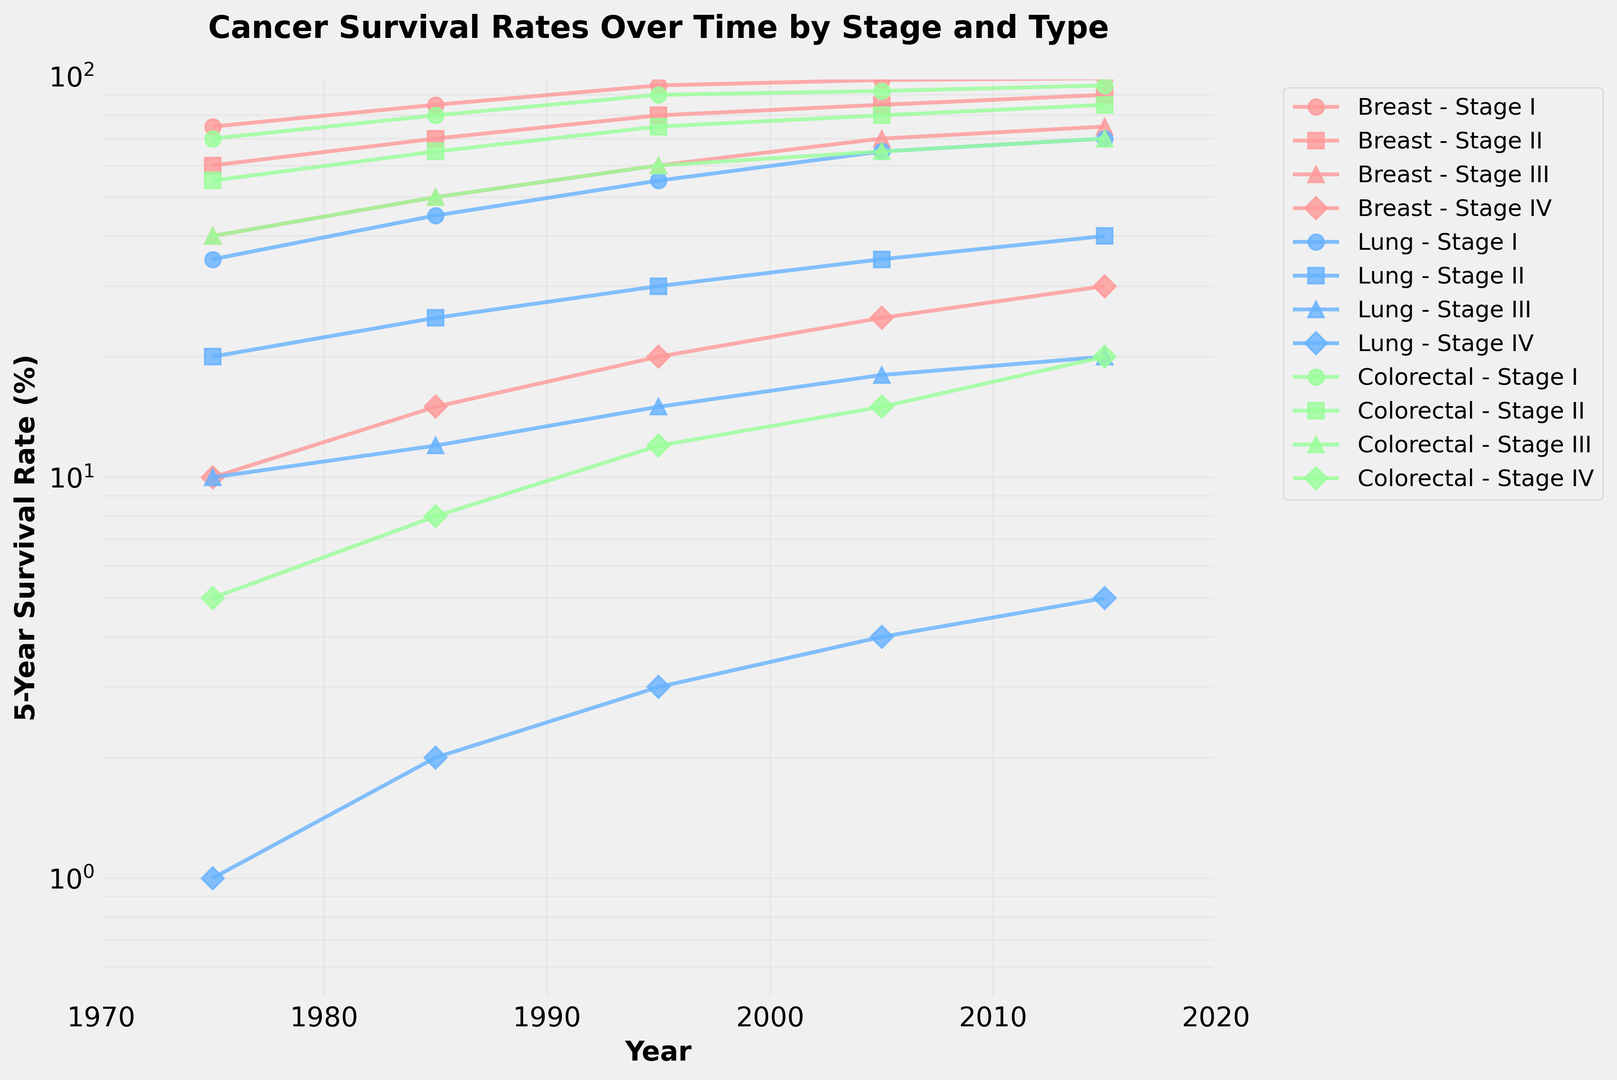What's the trend in the 5-year survival rate for Stage I Breast cancer from 1975 to 2015? The line corresponding to Stage I Breast cancer shows a consistent increase in survival rates over time. Observing the survival rate for Stage I Breast cancer at different time points—75% (1975), 85% (1985), 95% (1995), 98% (2005), and 99% (2015)—demonstrates this upward trend.
Answer: The survival rate increases Which cancer type had the lowest 5-year survival rate in 2015, and for which stage? We observe the lowest point on the graph in 2015 to find the minimum survival rate. Stage IV Lung cancer has the lowest survival rate in 2015, depicted by the Stage IV line for Lung cancer at approximately 5%.
Answer: Lung, Stage IV Between which two successive decades did Stage III Colorectal cancer show the greatest improvement in 5-year survival rate? Comparing the survival rate increments for each decade:
    - 1975 to 1985: 40% to 50% (10% increase)
    - 1985 to 1995: 50% to 60% (10% increase)
    - 1995 to 2005: 60% to 65% (5% increase)
    - 2005 to 2015: 65% to 70% (5% increase)
The greatest improvement of 10% is seen in both 1975-1985 and 1985-1995.
Answer: 1975 to 1985 and 1985 to 1995 Which cancer type has the highest 5-year survival rate in 2005 for Stage II, and what is that rate? Examining Stage II lines for the year 2005, Breast cancer shows an 85% survival rate, Lung cancer shows 35%, and Colorectal cancer shows 80%. Consequently, Breast cancer has the highest survival rate for Stage II in 2005.
Answer: Breast, 85% How does the 5-year survival rate for Stage IV cancers compare between Breast and Colorectal cancer in 2015? Locate Stage IV lines for both Breast and Colorectal cancers in 2015. Breast cancer shows a 30% survival rate, and Colorectal cancer shows 20%. Breast cancer’s survival rate is higher by 10%.
Answer: Breast cancer's rate is higher by 10% Which cancer type and stage had the most significant increase in survival rate from 1975 to 2015, and what is the total increase? By comparing starting (1975) and ending (2015) values for each stage:
    - Stage I Breast: 75% to 99% (24% increase)
    - Stage I Lung: 35% to 70% (35% increase)
    - Stage I Colorectal: 70% to 95% (25% increase)
    Lung cancer at Stage I shows the largest increase of 35% between 1975 and 2015.
Answer: Lung, Stage I, 35% What is the difference in 5-year survival rate for Stage III cancers of Lung and Colorectal cancer in 1995? Comparing the Stage III survival rates for Lung and Colorectal cancer in 1995:
    - Lung cancer: 15%
    - Colorectal cancer: 60%
The difference is 60% - 15% = 45%.
Answer: 45% For which stage and cancer type is there the smallest change in survival rates from 1975 to 2015? Reviewing survival rate changes:
    - Breast Stage IV: from 10% to 30% (20% change)
    - Lung Stage IV: from 1% to 5% (4% change)
    - Colorectal Stage IV: from 5% to 20% (15% change)
Lung cancer at Stage IV has the smallest change (4%).
Answer: Lung, Stage IV 